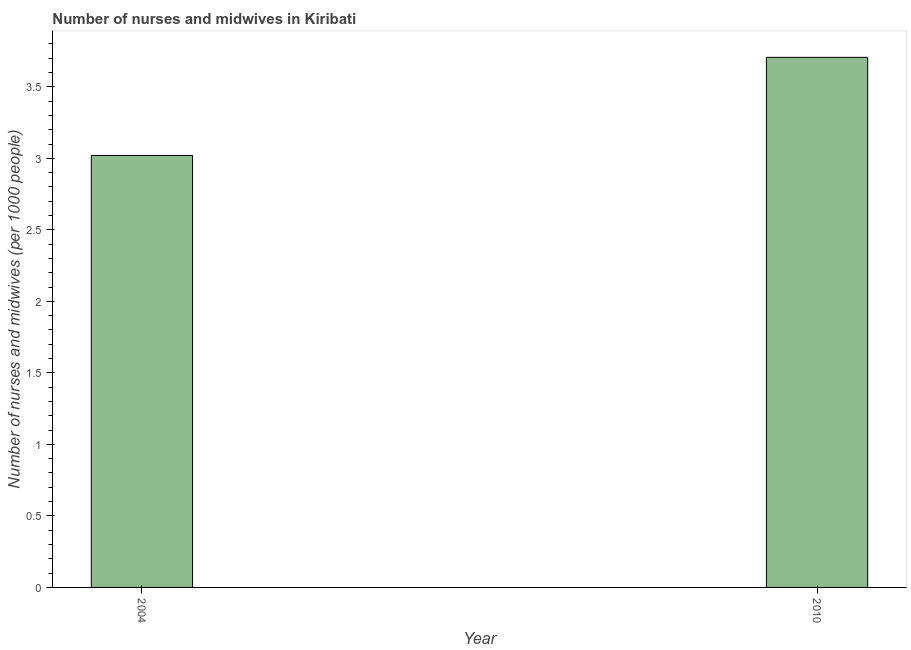Does the graph contain any zero values?
Provide a short and direct response. No. What is the title of the graph?
Provide a short and direct response. Number of nurses and midwives in Kiribati. What is the label or title of the X-axis?
Offer a terse response. Year. What is the label or title of the Y-axis?
Your response must be concise. Number of nurses and midwives (per 1000 people). What is the number of nurses and midwives in 2004?
Make the answer very short. 3.02. Across all years, what is the maximum number of nurses and midwives?
Your response must be concise. 3.71. Across all years, what is the minimum number of nurses and midwives?
Give a very brief answer. 3.02. In which year was the number of nurses and midwives maximum?
Provide a short and direct response. 2010. What is the sum of the number of nurses and midwives?
Provide a short and direct response. 6.73. What is the difference between the number of nurses and midwives in 2004 and 2010?
Your response must be concise. -0.69. What is the average number of nurses and midwives per year?
Your answer should be compact. 3.36. What is the median number of nurses and midwives?
Your answer should be compact. 3.36. In how many years, is the number of nurses and midwives greater than 1 ?
Make the answer very short. 2. Do a majority of the years between 2010 and 2004 (inclusive) have number of nurses and midwives greater than 2.9 ?
Keep it short and to the point. No. What is the ratio of the number of nurses and midwives in 2004 to that in 2010?
Keep it short and to the point. 0.81. Is the number of nurses and midwives in 2004 less than that in 2010?
Offer a terse response. Yes. In how many years, is the number of nurses and midwives greater than the average number of nurses and midwives taken over all years?
Provide a succinct answer. 1. Are the values on the major ticks of Y-axis written in scientific E-notation?
Offer a very short reply. No. What is the Number of nurses and midwives (per 1000 people) of 2004?
Your answer should be compact. 3.02. What is the Number of nurses and midwives (per 1000 people) in 2010?
Your answer should be very brief. 3.71. What is the difference between the Number of nurses and midwives (per 1000 people) in 2004 and 2010?
Your response must be concise. -0.69. What is the ratio of the Number of nurses and midwives (per 1000 people) in 2004 to that in 2010?
Offer a terse response. 0.81. 